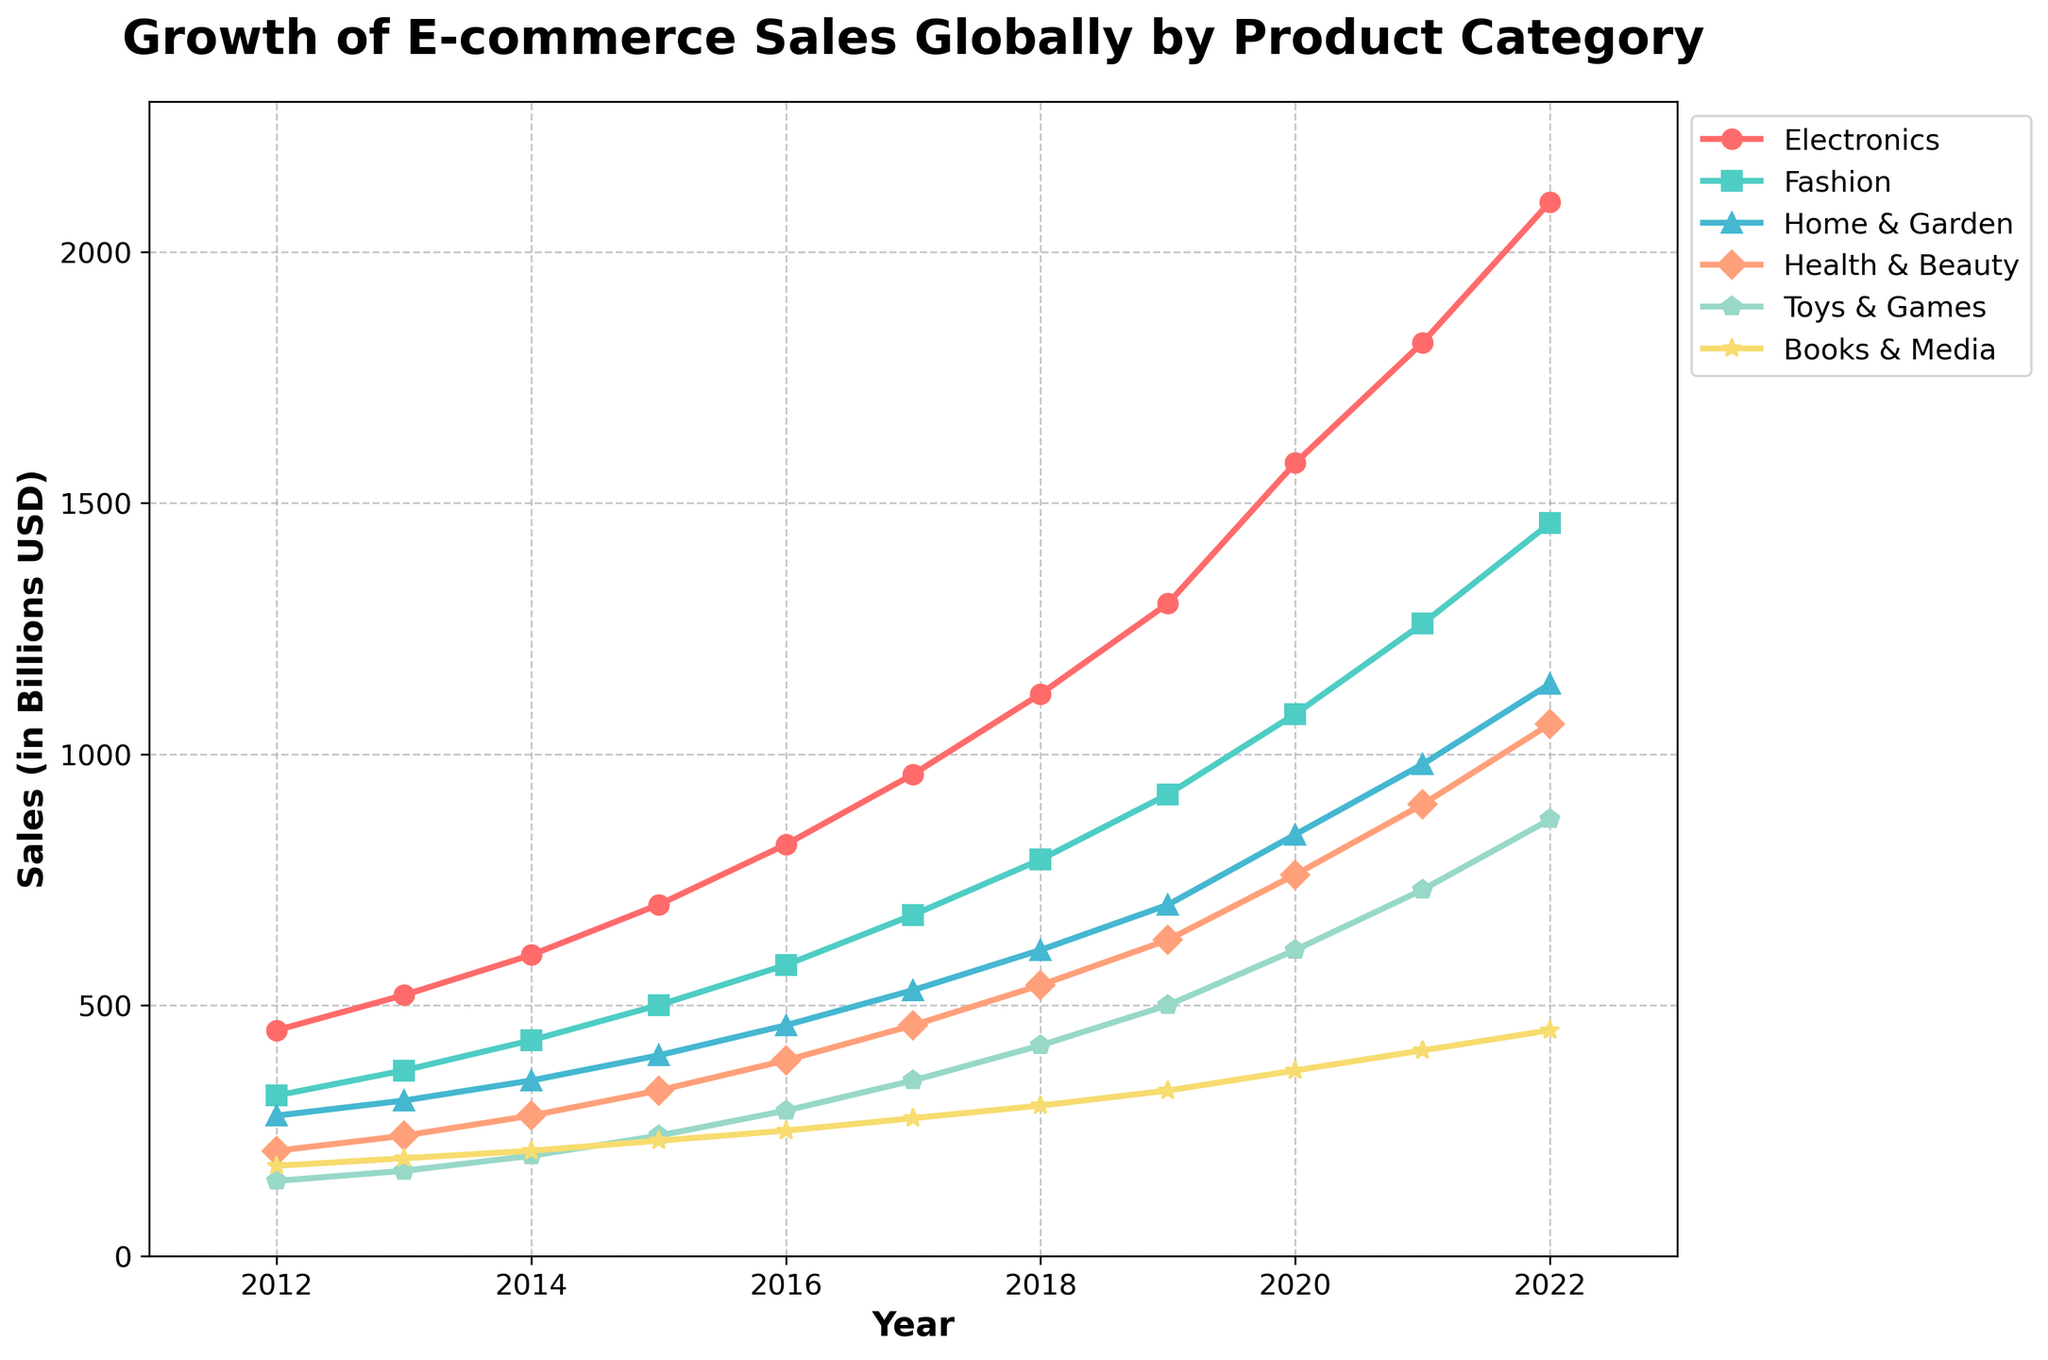Which product category saw the highest sales in 2022? By observing the rightmost points on the lines for each category in the chart, we see that the Electronics line is at the highest position in 2022.
Answer: Electronics Between which two consecutive years did Fashion sales see the greatest increase? Examining the yearly increments for Fashion, the gap between each year can be compared. The largest jump is from 2020 to 2021, where sales increased from 1080 to 1260.
Answer: 2020 to 2021 What is the average sales of Home & Garden between 2014 and 2018? The sales for Home & Garden from 2014 to 2018 are 350, 400, 460, 530, and 610. Summing them yields 2350, so dividing by 5 for the average: 2350/5.
Answer: 470 How do the sales of Toys & Games in 2022 compare to those in 2012? The sales in 2012 for Toys & Games were 150. In 2022, they were 870. Comparing these two values shows that the sales in 2022 are much larger.
Answer: Higher by 720 Which category had the lowest sales increase over the past decade? By examining the slope of each line over the decade, Books & Media shows the least steep trend indicating the lowest increase from 180 in 2012 to 450 in 2022.
Answer: Books & Media What was the sales difference between Electronics and Health & Beauty in 2019? In 2019, Electronics sales were 1300 and Health & Beauty were 630. Subtracting the smaller from the larger value gives us the difference: 1300 - 630.
Answer: 670 By how much did Health & Beauty sales grow from 2012 to 2022? The initial and final values for Health & Beauty are 210 in 2012 and 1060 in 2022. Subtract 210 from 1060 to find the growth.
Answer: 850 Which product category had a steady year-on-year increase judging by the smoothness of the line? Observing the chart, Home & Garden shows a very even upward trend with no sharp increases or decreases between years.
Answer: Home & Garden Comparing 2017 with 2020, which product category saw the largest absolute sales increase? By checking the difference between 2020 and 2017 for each category: Electronics (620), Fashion (400), Home & Garden (310), Health & Beauty (300), Toys & Games (260), Books & Media (95). Electronics has the largest absolute increase.
Answer: Electronics Which product category saw the slowest growth rate between 2014 and 2019? By calculating the growth rate for each category over this period (using the difference between 2014 and 2019 and dividing by the 2014 value), Books & Media has the lowest rate of growth.
Answer: Books & Media 